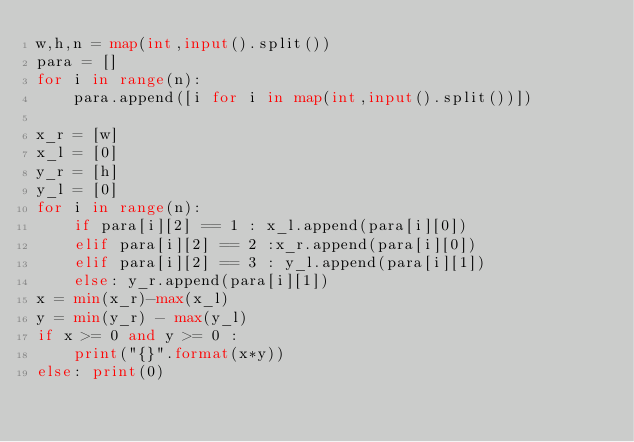<code> <loc_0><loc_0><loc_500><loc_500><_Python_>w,h,n = map(int,input().split())
para = []
for i in range(n):
    para.append([i for i in map(int,input().split())])

x_r = [w]
x_l = [0]
y_r = [h]
y_l = [0]
for i in range(n):
    if para[i][2] == 1 : x_l.append(para[i][0])
    elif para[i][2] == 2 :x_r.append(para[i][0])
    elif para[i][2] == 3 : y_l.append(para[i][1])
    else: y_r.append(para[i][1])
x = min(x_r)-max(x_l)
y = min(y_r) - max(y_l)
if x >= 0 and y >= 0 : 
    print("{}".format(x*y))
else: print(0)</code> 